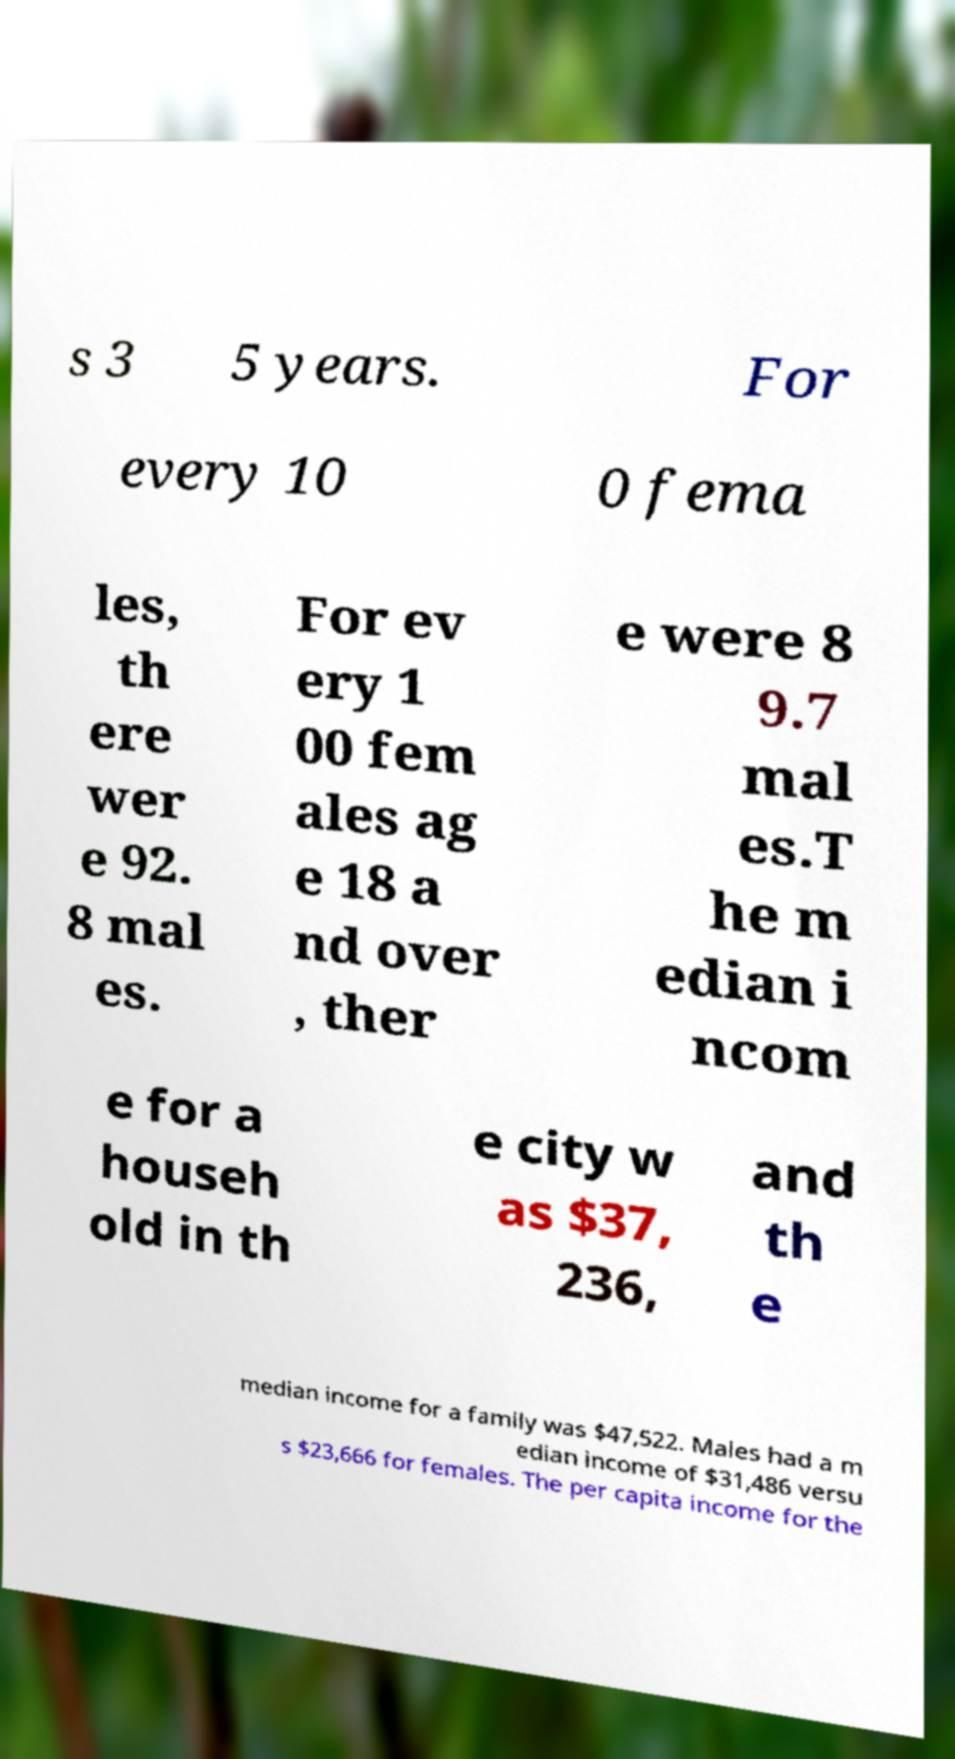There's text embedded in this image that I need extracted. Can you transcribe it verbatim? s 3 5 years. For every 10 0 fema les, th ere wer e 92. 8 mal es. For ev ery 1 00 fem ales ag e 18 a nd over , ther e were 8 9.7 mal es.T he m edian i ncom e for a househ old in th e city w as $37, 236, and th e median income for a family was $47,522. Males had a m edian income of $31,486 versu s $23,666 for females. The per capita income for the 